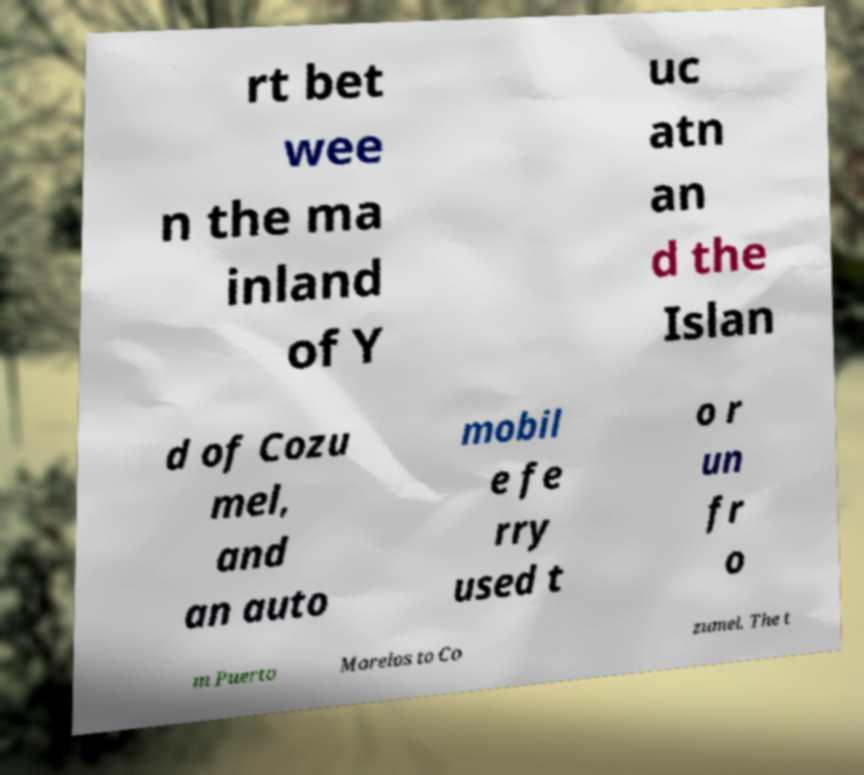Could you extract and type out the text from this image? rt bet wee n the ma inland of Y uc atn an d the Islan d of Cozu mel, and an auto mobil e fe rry used t o r un fr o m Puerto Morelos to Co zumel. The t 